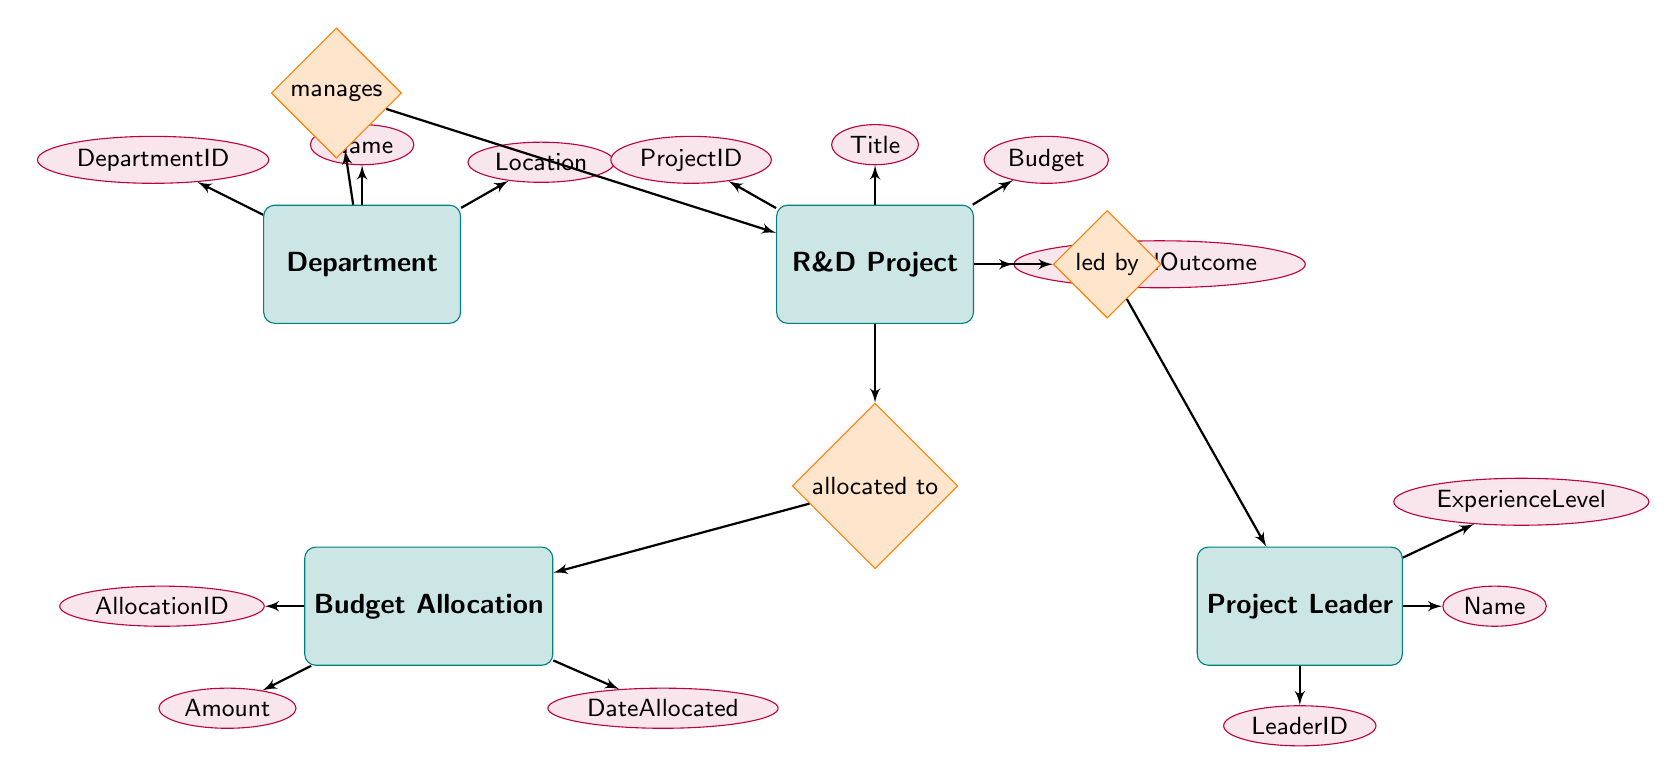What entities are present in the diagram? The diagram contains four entities: Department, R&D Project, Project Leader, and Budget Allocation. Each entity is represented as a rectangle and has specific attributes.
Answer: Department, R&D Project, Project Leader, Budget Allocation How many attributes does the R&D Project entity have? The R&D Project entity has four attributes: ProjectID, Title, Budget, and ExpectedOutcome. Each attribute is depicted as an ellipse, showing the basic properties of the entity.
Answer: Four What relationship exists between Department and R&D Project? The diagram shows a "manages" relationship between the Department and R&D Project entities. This indicates that each department is responsible for managing one or more R&D projects.
Answer: manages Which entity is led by the Project Leader? The R&D Project entity is led by the Project Leader, as indicated by the "led by" relationship connecting these two entities. This implies that each project has a designated leader overseeing it.
Answer: R&D Project What is the connection between R&D Project and Budget Allocation? The R&D Project is connected to Budget Allocation through the "allocated to" relationship. This indicates the financial resources allocated to each R&D project.
Answer: allocated to How many relationships are there in total in the diagram? The diagram includes a total of three relationships: manages, led by, and allocated to. Each relationship describes how the entities interact with one another.
Answer: Three What is an expected outcome of the R&D Project? The expected outcome is one of the attributes of the R&D Project entity, indicating what the project aims to achieve or the results anticipated upon its completion.
Answer: ExpectedOutcome What type of information does the Budget Allocation entity provide? The Budget Allocation entity provides information about financial resources for projects. It includes attributes like AllocationID, Amount, and DateAllocated, which detail budget specifics.
Answer: Amount, DateAllocated How does experience level relate to Project Leader? The experience level is an attribute of the Project Leader entity, which helps assess the competency or capability of the leader in managing R&D projects.
Answer: ExperienceLevel 